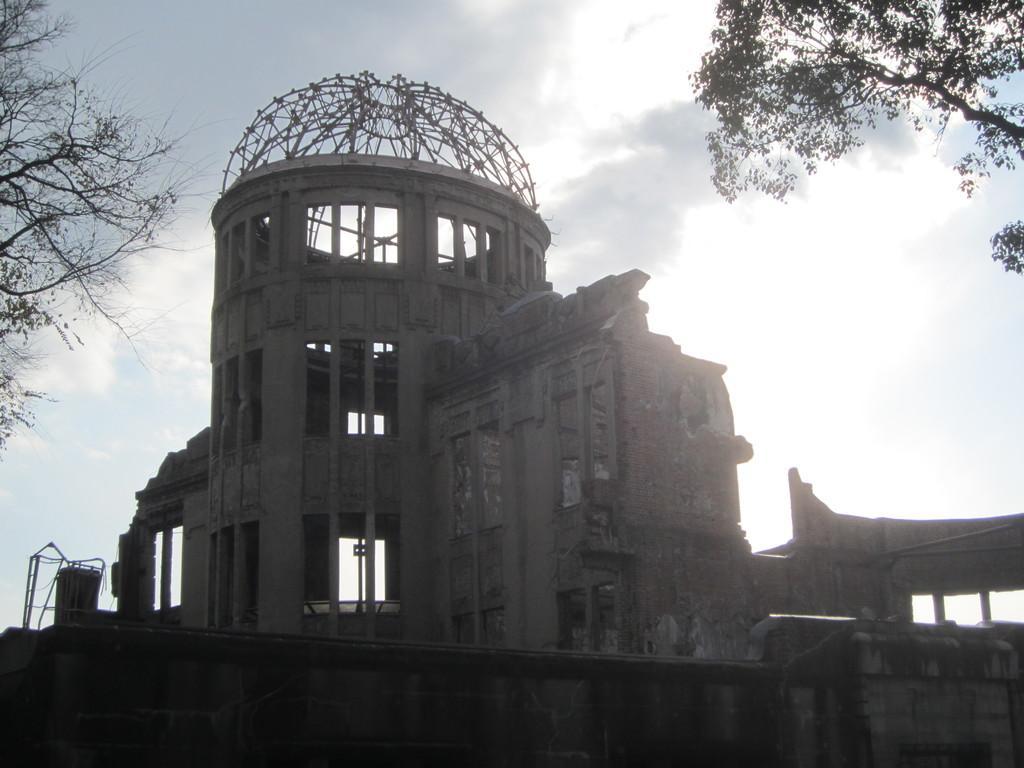Describe this image in one or two sentences. In this picture there are buildings in the center of the image and there are trees in the top right and left side of the image. 